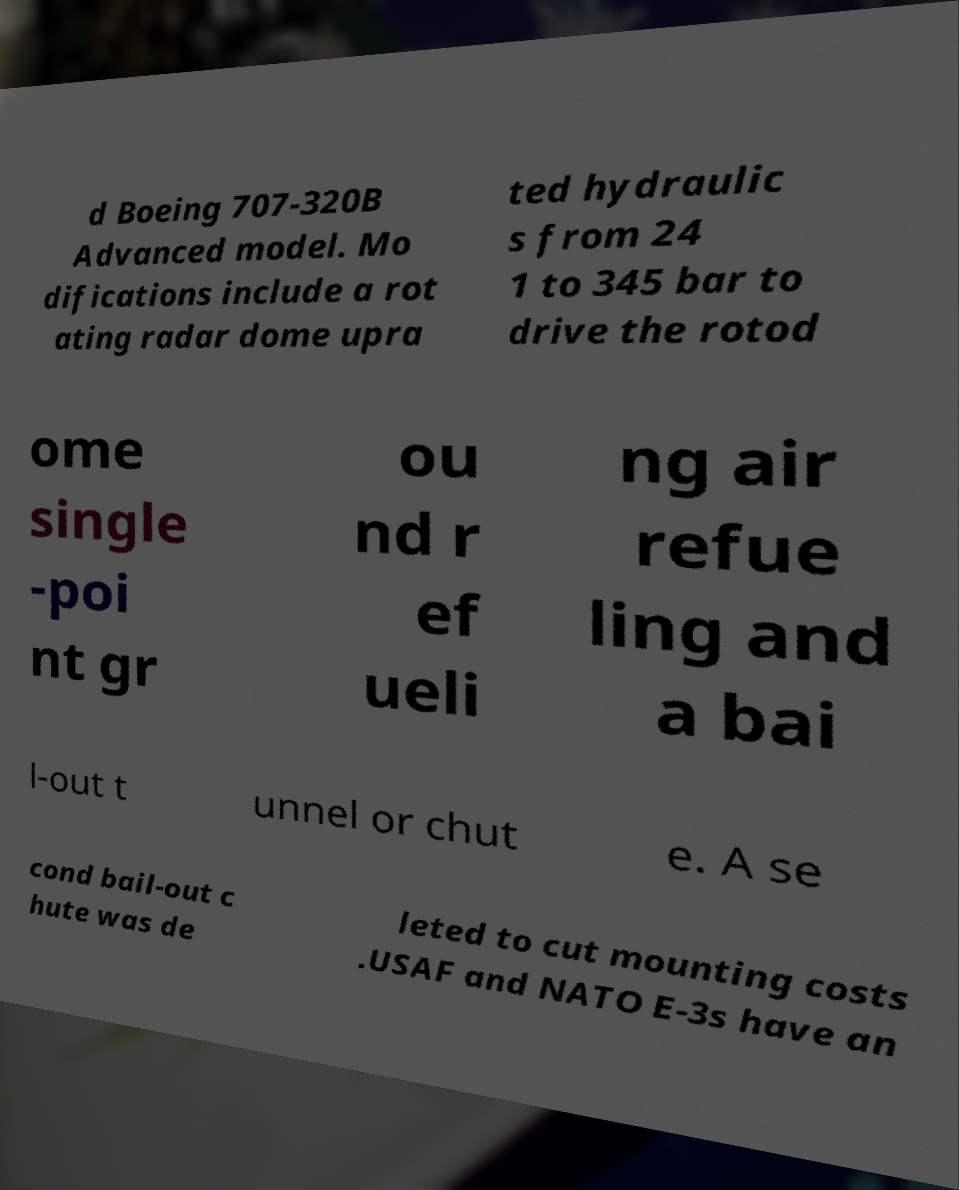For documentation purposes, I need the text within this image transcribed. Could you provide that? d Boeing 707-320B Advanced model. Mo difications include a rot ating radar dome upra ted hydraulic s from 24 1 to 345 bar to drive the rotod ome single -poi nt gr ou nd r ef ueli ng air refue ling and a bai l-out t unnel or chut e. A se cond bail-out c hute was de leted to cut mounting costs .USAF and NATO E-3s have an 